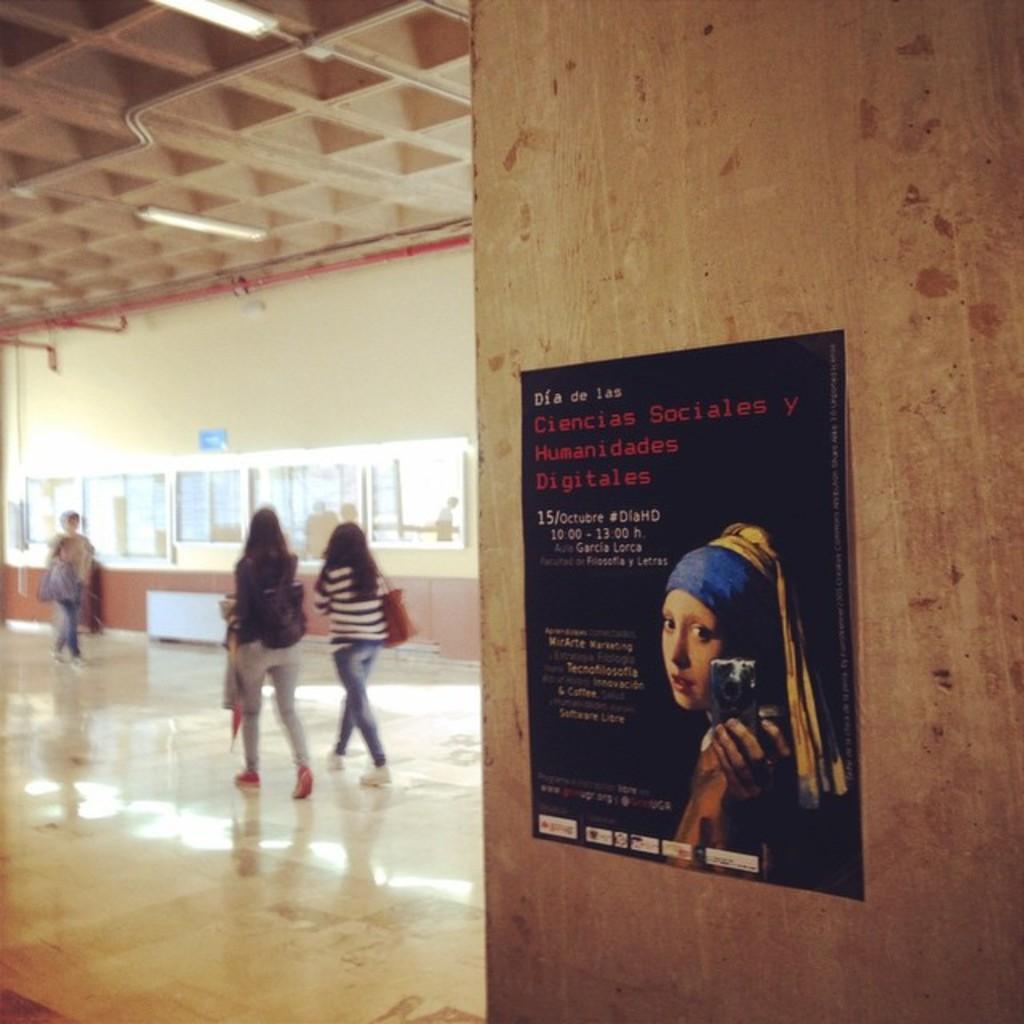Can you describe this image briefly? In this image I can see few people walking on the floor, beside them there is a poster on the wall. 